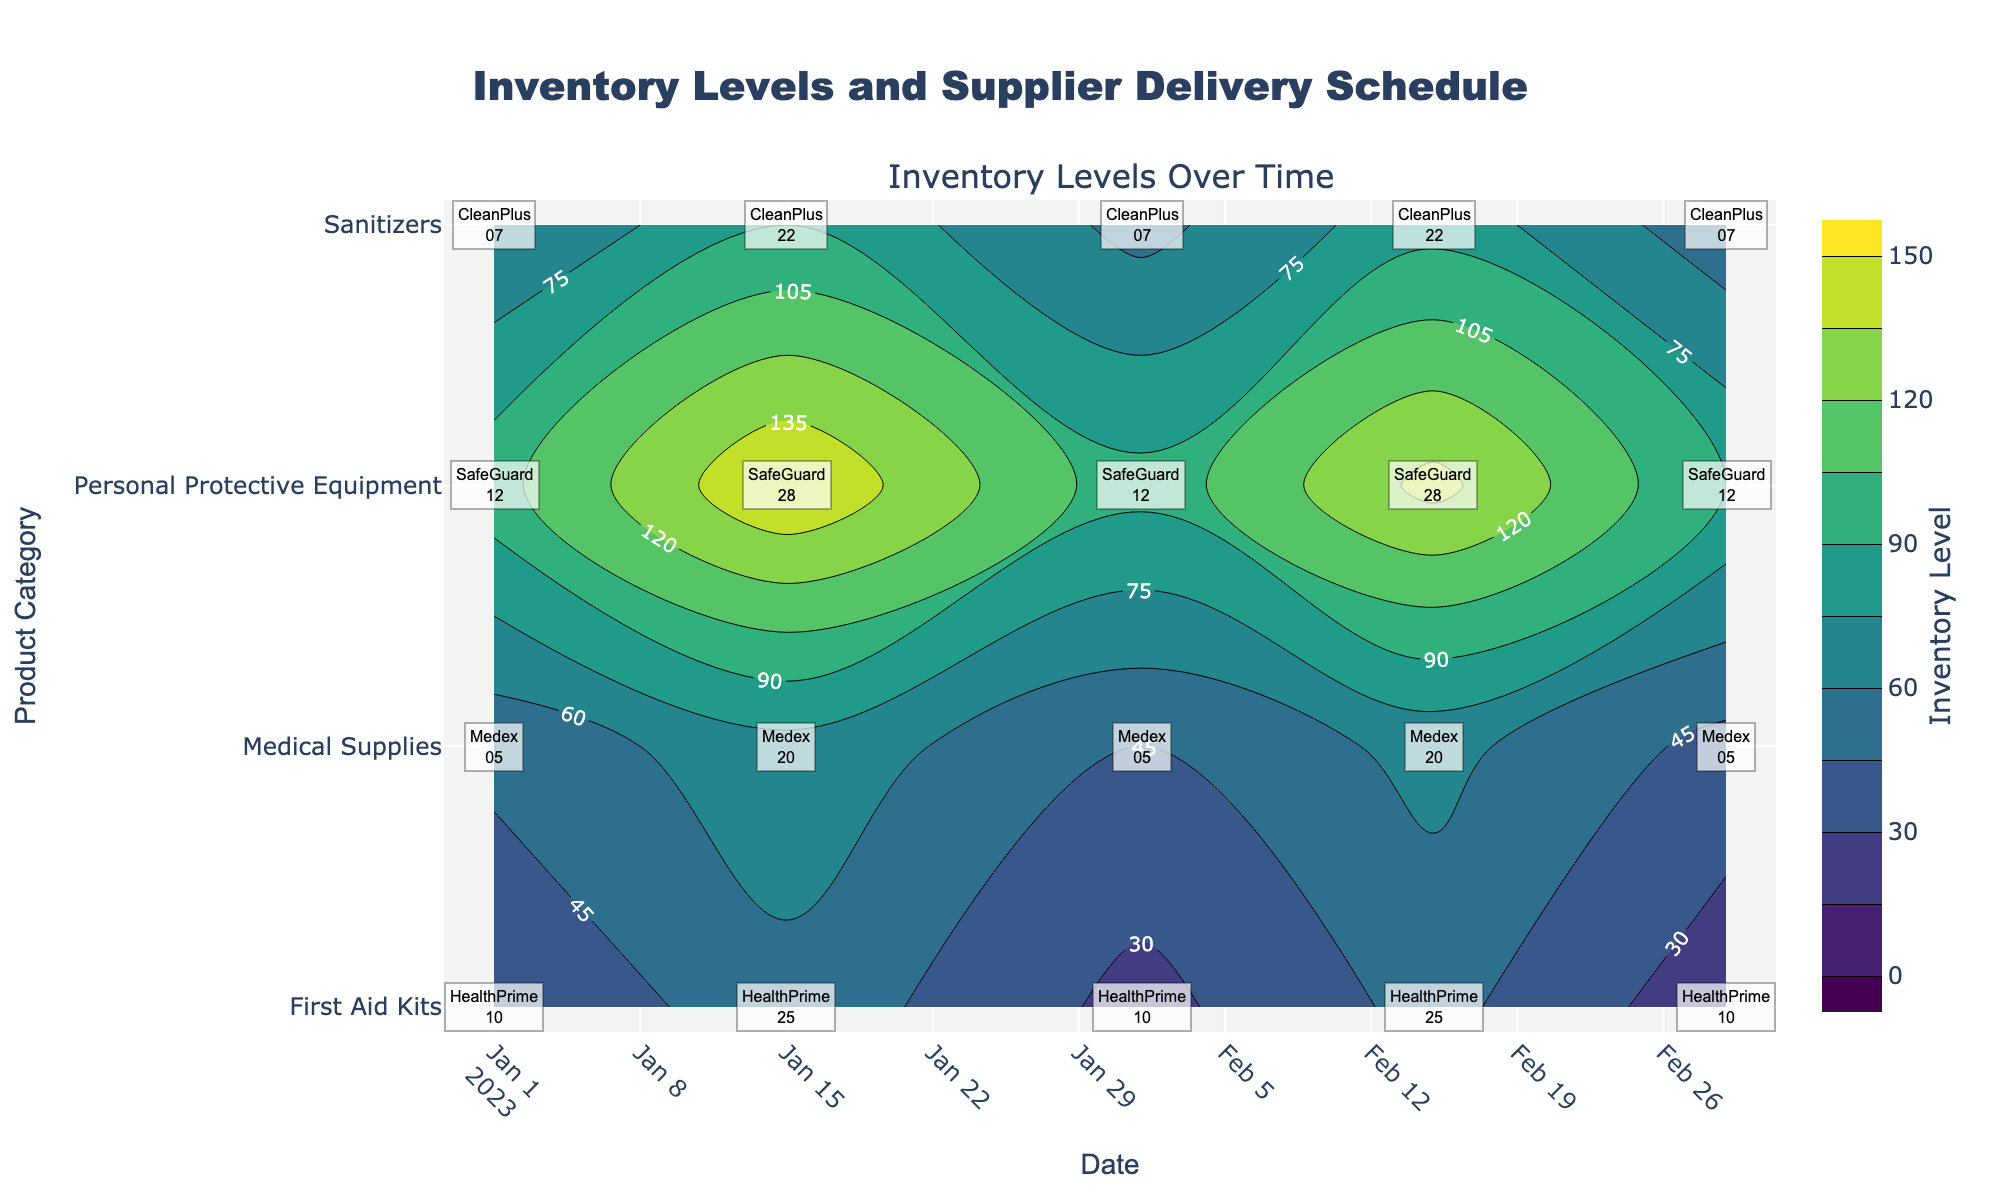What is the title of the figure? The title of the figure is prominently displayed at the top of the figure. It reads "Inventory Levels and Supplier Delivery Schedule".
Answer: "Inventory Levels and Supplier Delivery Schedule" Which product category has the highest inventory level on March 1, 2023? To find the highest inventory level on a specific date, we look at the contour plot and check the labels for each product category on March 1, 2023. The highest value is found for "Personal Protective Equipment" with an inventory level of 90.
Answer: Personal Protective Equipment What is the range of inventory levels shown in the contour plot? The color bar indicates the range of inventory levels represented by the contour plot. It shows values starting from 0 and ending at 150.
Answer: 0 to 150 On January 15, 2023, which product category received the delivery from the supplier "HealthPrime"? By examining the annotations in the figure corresponding to January 15, 2023, we find that "First Aid Kits" received a delivery from "HealthPrime".
Answer: First Aid Kits Compare the inventory levels of "Sanitizers" and "Medical Supplies" on February 01, 2023. Which category had more inventory? By examining the inventory levels on February 01, 2023 for both categories, we see that "Sanitizers" had an inventory level of 55 while "Medical Supplies" had 45. Therefore, "Sanitizers" had a higher inventory level.
Answer: Sanitizers How often does the supplier "CleanPlus" deliver Sanitizers? To determine the frequency of deliveries from "CleanPlus" for Sanitizers, look at the annotations for "Sanitizers". Deliveries are on 2023-01-07, 2023-01-22, 2023-02-07, 2023-02-22, 2023-03-07. The pattern shows a consistent interval, approximately every 15 days.
Answer: Approximately every 15 days What are the average inventory levels for "First Aid Kits" in January 2023? Calculate the average by adding the inventory levels in January and dividing by the number of data points: (30 on Jan 01 + 55 on Jan 15) / 2 = 85 / 2 = 42.5.
Answer: 42.5 What is the general trend in inventory levels for "Personal Protective Equipment" from January to March 2023? By following the contour lines for "Personal Protective Equipment" across the timeline from January to March, we notice the inventory level starts high at 100, peaks at 150 on Jan 15, and then gradually decreases through February and March.
Answer: Decreasing trend During which dates did the "Medex" supplier deliver "Medical Supplies"? The annotations for "Medical Supplies" indicate deliveries from "Medex" on 2023-01-05, 2023-01-20, 2023-02-05, 2023-02-20, and 2023-03-05.
Answer: 2023-01-05, 2023-01-20, 2023-02-05, 2023-02-20, 2023-03-05 How does the inventory level fluctuation for "Sanitizers" compare to that of "First Aid Kits" over the three months? The "Sanitizers" category shows recurring peaks and troughs whereas "First Aid Kits" show a sharp rise followed by steady declines. For "Sanitizers," the inventory fluctuates significantly between 50 and 90, while "First Aid Kits" have smaller fluctuations between 20 and 55.
Answer: More fluctuation in Sanitizers 